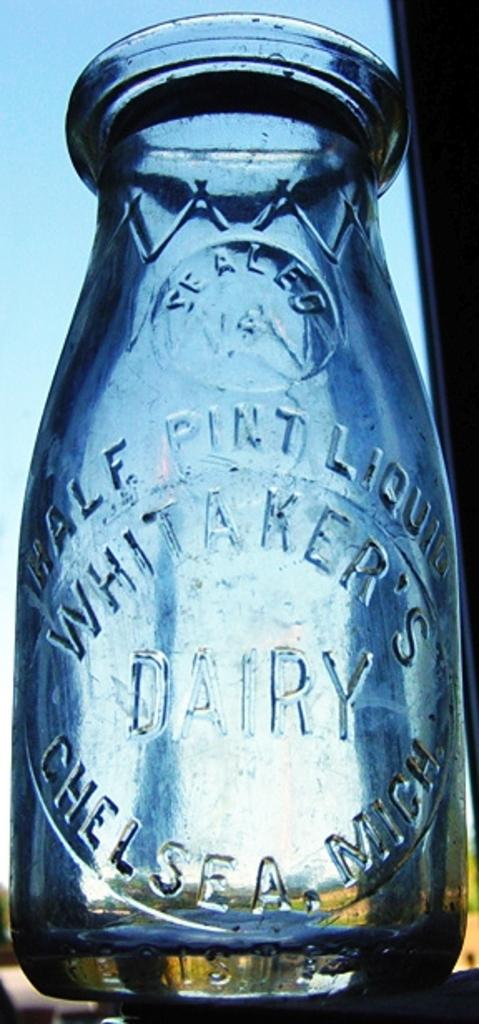<image>
Provide a brief description of the given image. A glass dairy container sits outside on a clear day. 